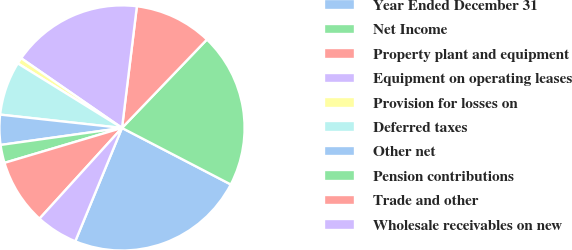<chart> <loc_0><loc_0><loc_500><loc_500><pie_chart><fcel>Year Ended December 31<fcel>Net Income<fcel>Property plant and equipment<fcel>Equipment on operating leases<fcel>Provision for losses on<fcel>Deferred taxes<fcel>Other net<fcel>Pension contributions<fcel>Trade and other<fcel>Wholesale receivables on new<nl><fcel>23.6%<fcel>20.45%<fcel>10.24%<fcel>17.31%<fcel>0.8%<fcel>7.09%<fcel>3.95%<fcel>2.38%<fcel>8.66%<fcel>5.52%<nl></chart> 